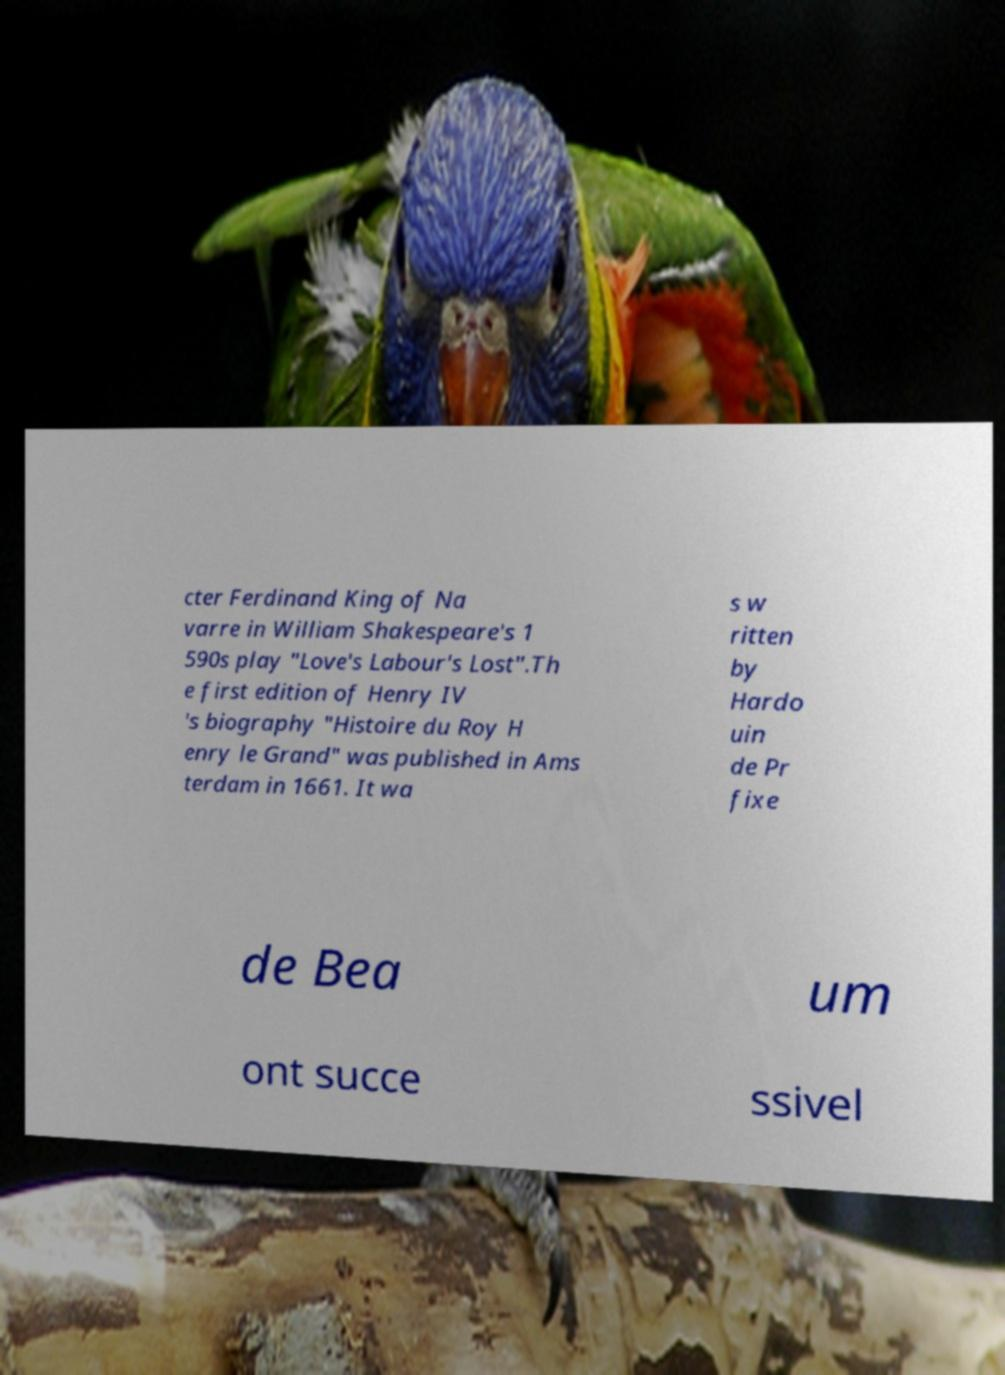Can you read and provide the text displayed in the image?This photo seems to have some interesting text. Can you extract and type it out for me? cter Ferdinand King of Na varre in William Shakespeare's 1 590s play "Love's Labour's Lost".Th e first edition of Henry IV 's biography "Histoire du Roy H enry le Grand" was published in Ams terdam in 1661. It wa s w ritten by Hardo uin de Pr fixe de Bea um ont succe ssivel 